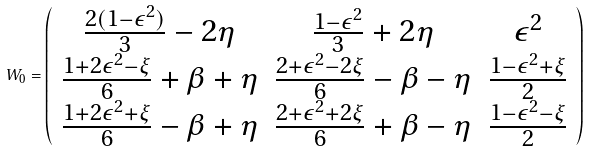Convert formula to latex. <formula><loc_0><loc_0><loc_500><loc_500>W _ { 0 } = \left ( \begin{array} { c c c } \frac { 2 ( 1 - \epsilon ^ { 2 } ) } { 3 } - 2 \eta & \frac { 1 - \epsilon ^ { 2 } } { 3 } + 2 \eta & \epsilon ^ { 2 } \\ \frac { 1 + 2 \epsilon ^ { 2 } - \xi } { 6 } + \beta + \eta & \frac { 2 + \epsilon ^ { 2 } - 2 \xi } { 6 } - \beta - \eta & \frac { 1 - \epsilon ^ { 2 } + \xi } { 2 } \\ \frac { 1 + 2 \epsilon ^ { 2 } + \xi } { 6 } - \beta + \eta & \frac { 2 + \epsilon ^ { 2 } + 2 \xi } { 6 } + \beta - \eta & \frac { 1 - \epsilon ^ { 2 } - \xi } { 2 } \\ \end{array} \right )</formula> 